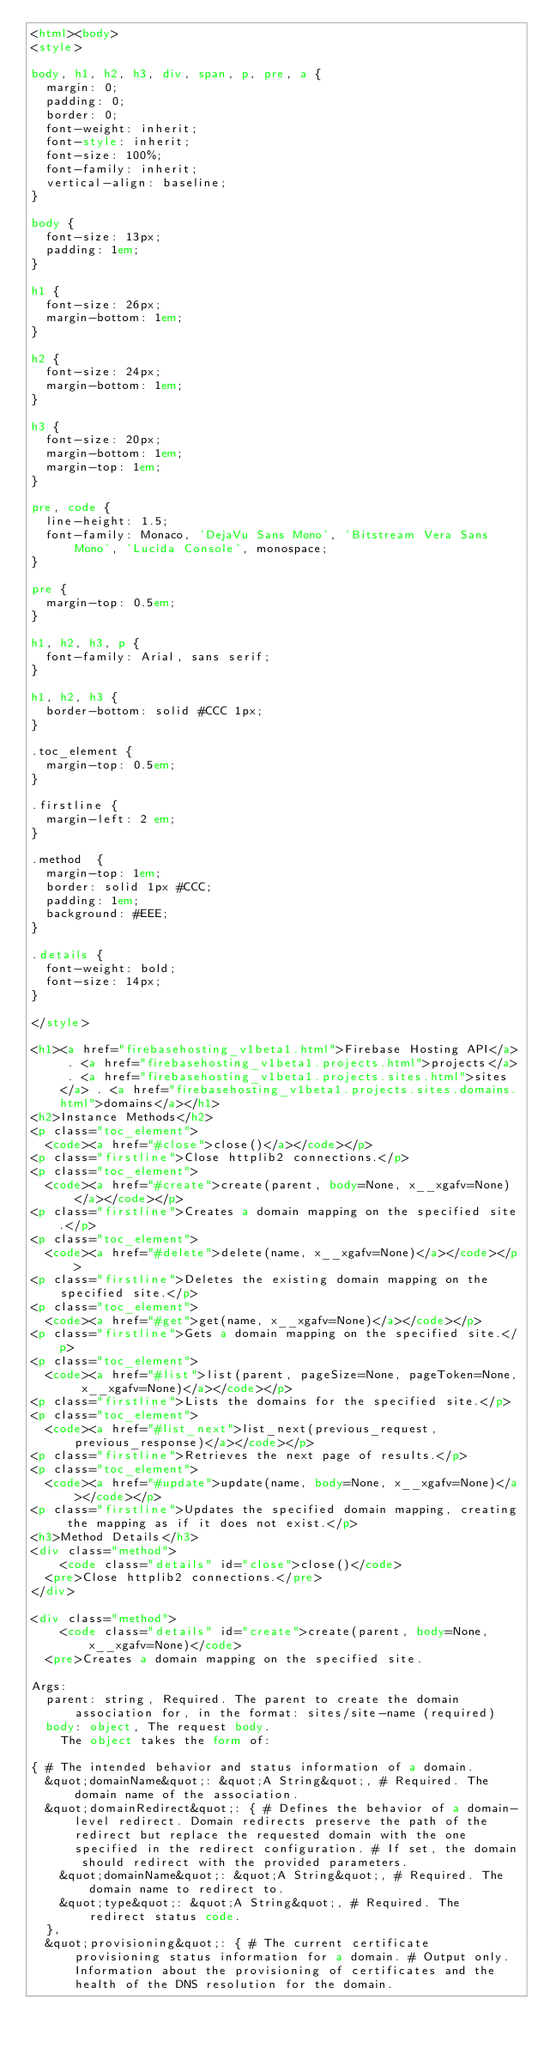Convert code to text. <code><loc_0><loc_0><loc_500><loc_500><_HTML_><html><body>
<style>

body, h1, h2, h3, div, span, p, pre, a {
  margin: 0;
  padding: 0;
  border: 0;
  font-weight: inherit;
  font-style: inherit;
  font-size: 100%;
  font-family: inherit;
  vertical-align: baseline;
}

body {
  font-size: 13px;
  padding: 1em;
}

h1 {
  font-size: 26px;
  margin-bottom: 1em;
}

h2 {
  font-size: 24px;
  margin-bottom: 1em;
}

h3 {
  font-size: 20px;
  margin-bottom: 1em;
  margin-top: 1em;
}

pre, code {
  line-height: 1.5;
  font-family: Monaco, 'DejaVu Sans Mono', 'Bitstream Vera Sans Mono', 'Lucida Console', monospace;
}

pre {
  margin-top: 0.5em;
}

h1, h2, h3, p {
  font-family: Arial, sans serif;
}

h1, h2, h3 {
  border-bottom: solid #CCC 1px;
}

.toc_element {
  margin-top: 0.5em;
}

.firstline {
  margin-left: 2 em;
}

.method  {
  margin-top: 1em;
  border: solid 1px #CCC;
  padding: 1em;
  background: #EEE;
}

.details {
  font-weight: bold;
  font-size: 14px;
}

</style>

<h1><a href="firebasehosting_v1beta1.html">Firebase Hosting API</a> . <a href="firebasehosting_v1beta1.projects.html">projects</a> . <a href="firebasehosting_v1beta1.projects.sites.html">sites</a> . <a href="firebasehosting_v1beta1.projects.sites.domains.html">domains</a></h1>
<h2>Instance Methods</h2>
<p class="toc_element">
  <code><a href="#close">close()</a></code></p>
<p class="firstline">Close httplib2 connections.</p>
<p class="toc_element">
  <code><a href="#create">create(parent, body=None, x__xgafv=None)</a></code></p>
<p class="firstline">Creates a domain mapping on the specified site.</p>
<p class="toc_element">
  <code><a href="#delete">delete(name, x__xgafv=None)</a></code></p>
<p class="firstline">Deletes the existing domain mapping on the specified site.</p>
<p class="toc_element">
  <code><a href="#get">get(name, x__xgafv=None)</a></code></p>
<p class="firstline">Gets a domain mapping on the specified site.</p>
<p class="toc_element">
  <code><a href="#list">list(parent, pageSize=None, pageToken=None, x__xgafv=None)</a></code></p>
<p class="firstline">Lists the domains for the specified site.</p>
<p class="toc_element">
  <code><a href="#list_next">list_next(previous_request, previous_response)</a></code></p>
<p class="firstline">Retrieves the next page of results.</p>
<p class="toc_element">
  <code><a href="#update">update(name, body=None, x__xgafv=None)</a></code></p>
<p class="firstline">Updates the specified domain mapping, creating the mapping as if it does not exist.</p>
<h3>Method Details</h3>
<div class="method">
    <code class="details" id="close">close()</code>
  <pre>Close httplib2 connections.</pre>
</div>

<div class="method">
    <code class="details" id="create">create(parent, body=None, x__xgafv=None)</code>
  <pre>Creates a domain mapping on the specified site.

Args:
  parent: string, Required. The parent to create the domain association for, in the format: sites/site-name (required)
  body: object, The request body.
    The object takes the form of:

{ # The intended behavior and status information of a domain.
  &quot;domainName&quot;: &quot;A String&quot;, # Required. The domain name of the association.
  &quot;domainRedirect&quot;: { # Defines the behavior of a domain-level redirect. Domain redirects preserve the path of the redirect but replace the requested domain with the one specified in the redirect configuration. # If set, the domain should redirect with the provided parameters.
    &quot;domainName&quot;: &quot;A String&quot;, # Required. The domain name to redirect to.
    &quot;type&quot;: &quot;A String&quot;, # Required. The redirect status code.
  },
  &quot;provisioning&quot;: { # The current certificate provisioning status information for a domain. # Output only. Information about the provisioning of certificates and the health of the DNS resolution for the domain.</code> 